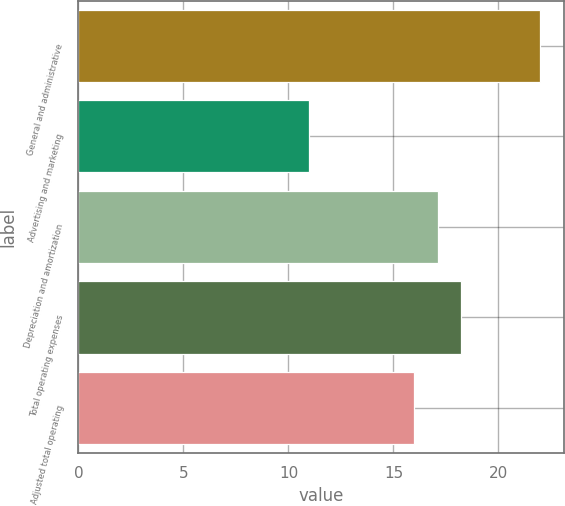Convert chart to OTSL. <chart><loc_0><loc_0><loc_500><loc_500><bar_chart><fcel>General and administrative<fcel>Advertising and marketing<fcel>Depreciation and amortization<fcel>Total operating expenses<fcel>Adjusted total operating<nl><fcel>22<fcel>11<fcel>17.1<fcel>18.2<fcel>16<nl></chart> 